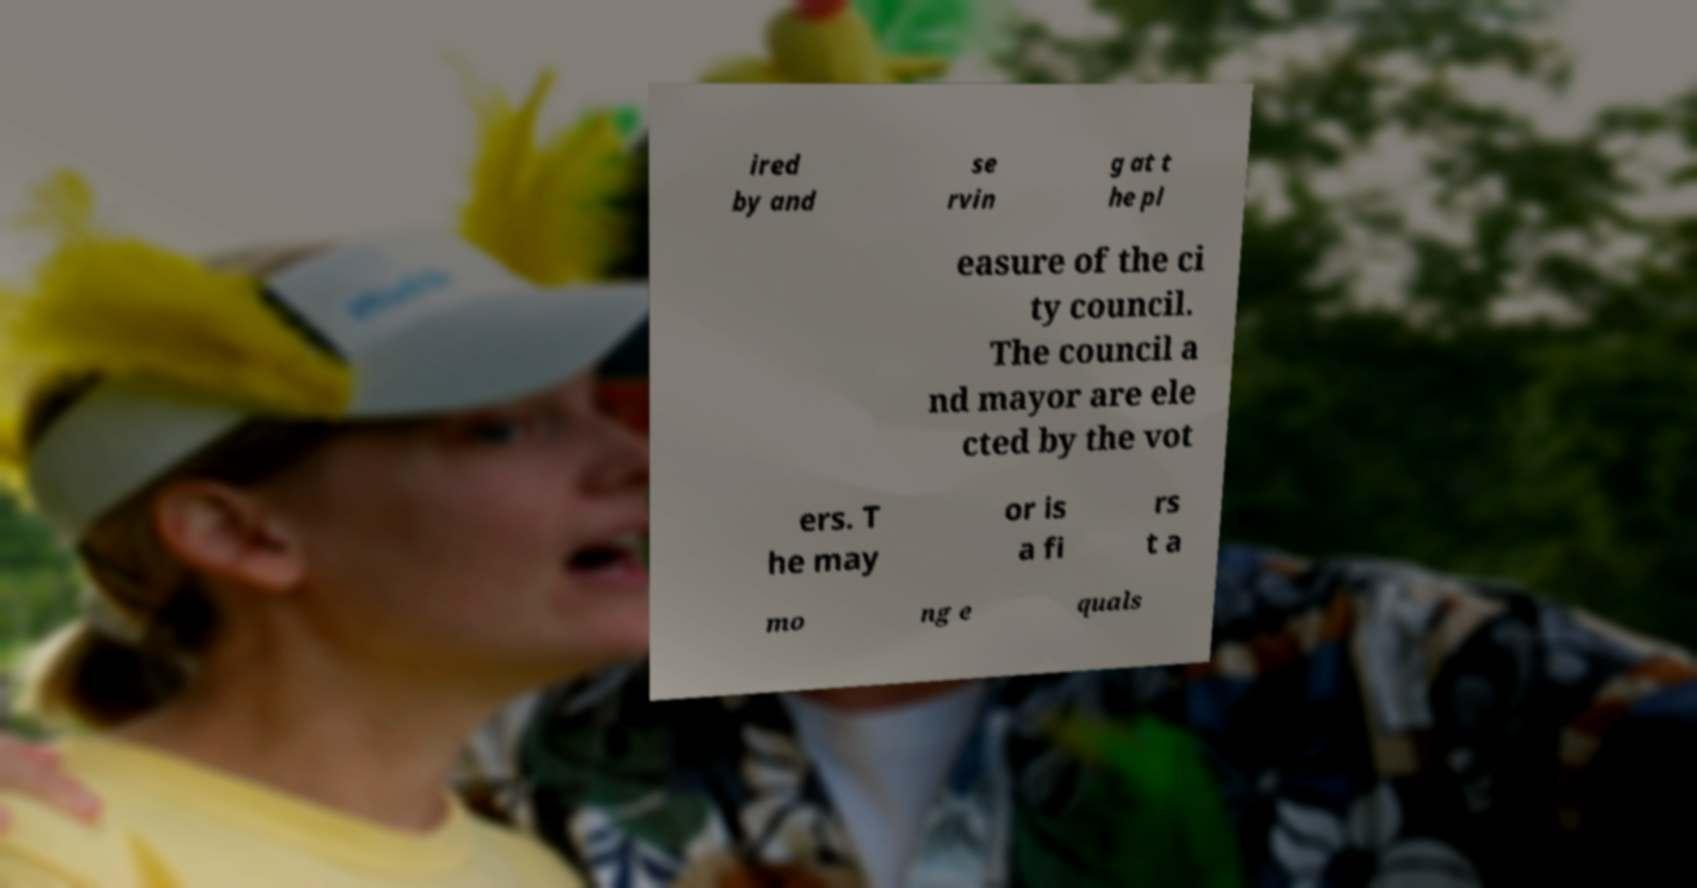Can you accurately transcribe the text from the provided image for me? ired by and se rvin g at t he pl easure of the ci ty council. The council a nd mayor are ele cted by the vot ers. T he may or is a fi rs t a mo ng e quals 